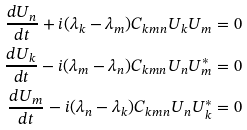<formula> <loc_0><loc_0><loc_500><loc_500>\frac { d U _ { n } } { d t } + i ( \lambda _ { k } - \lambda _ { m } ) C _ { k m n } U _ { k } U _ { m } = 0 \\ \frac { d U _ { k } } { d t } - i ( \lambda _ { m } - \lambda _ { n } ) C _ { k m n } U _ { n } U _ { m } ^ { * } = 0 \\ \frac { d U _ { m } } { d t } - i ( \lambda _ { n } - \lambda _ { k } ) C _ { k m n } U _ { n } U _ { k } ^ { * } = 0</formula> 